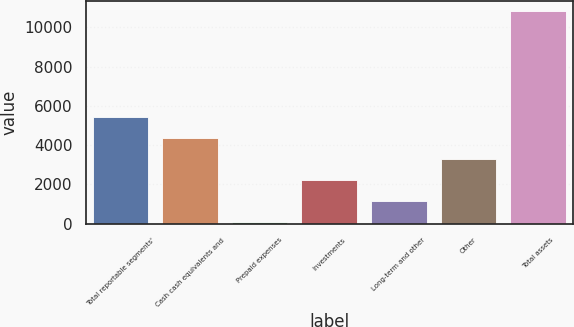Convert chart to OTSL. <chart><loc_0><loc_0><loc_500><loc_500><bar_chart><fcel>Total reportable segments'<fcel>Cash cash equivalents and<fcel>Prepaid expenses<fcel>Investments<fcel>Long-term and other<fcel>Other<fcel>Total assets<nl><fcel>5450<fcel>4377<fcel>85<fcel>2231<fcel>1158<fcel>3304<fcel>10815<nl></chart> 